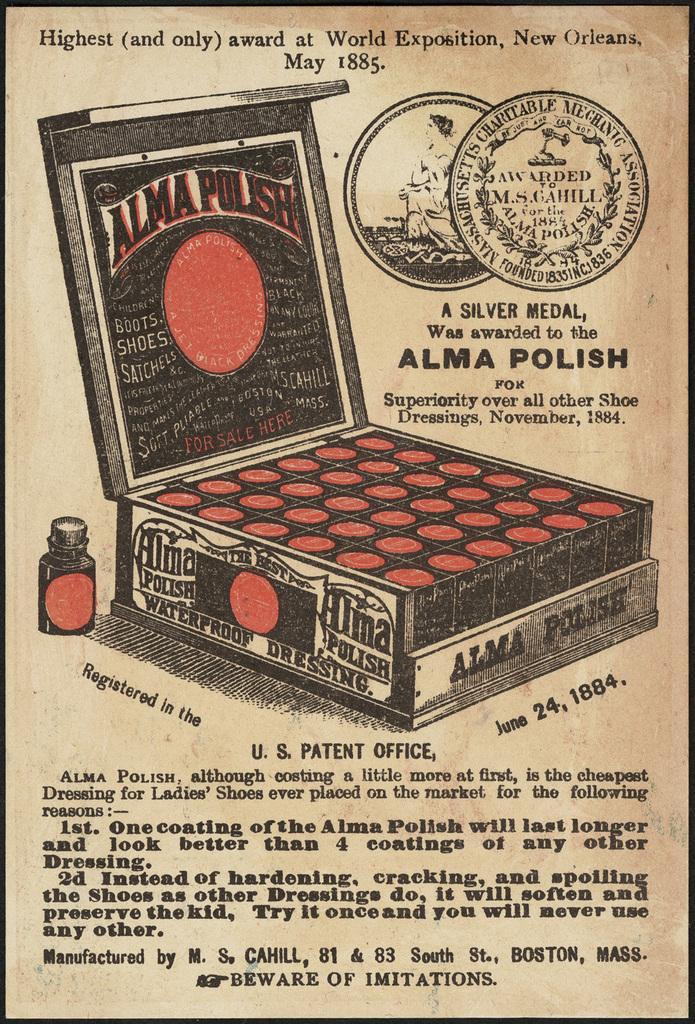Provide a one-sentence caption for the provided image. An old advertisement for Alma Polish proclaims that the product is superior. 